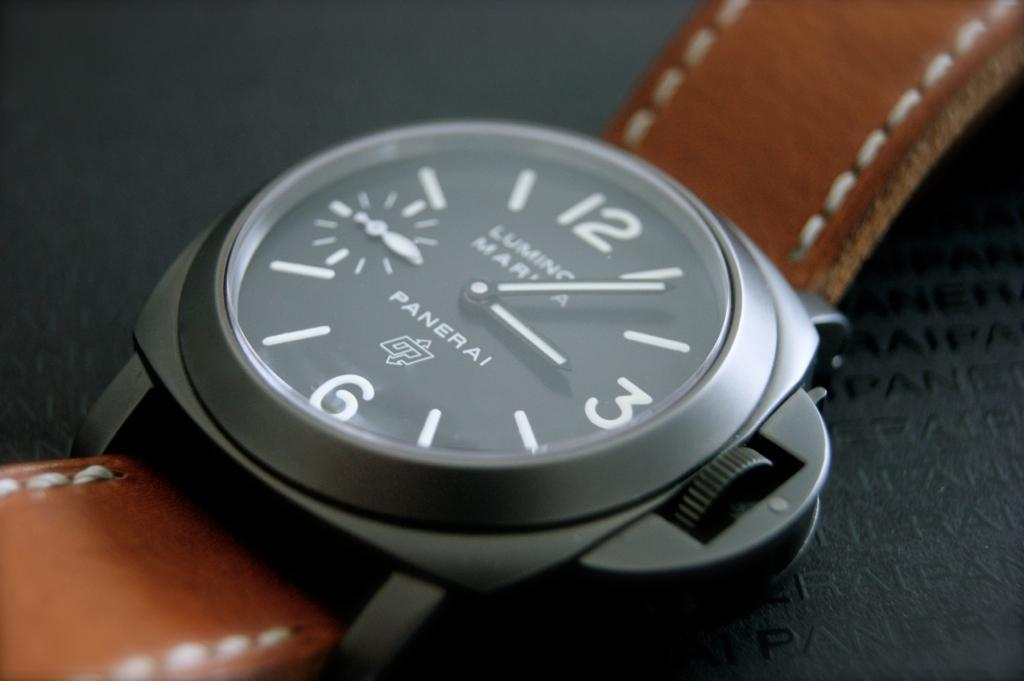<image>
Give a short and clear explanation of the subsequent image. A Panerai watch with a brown leather strap on it. 